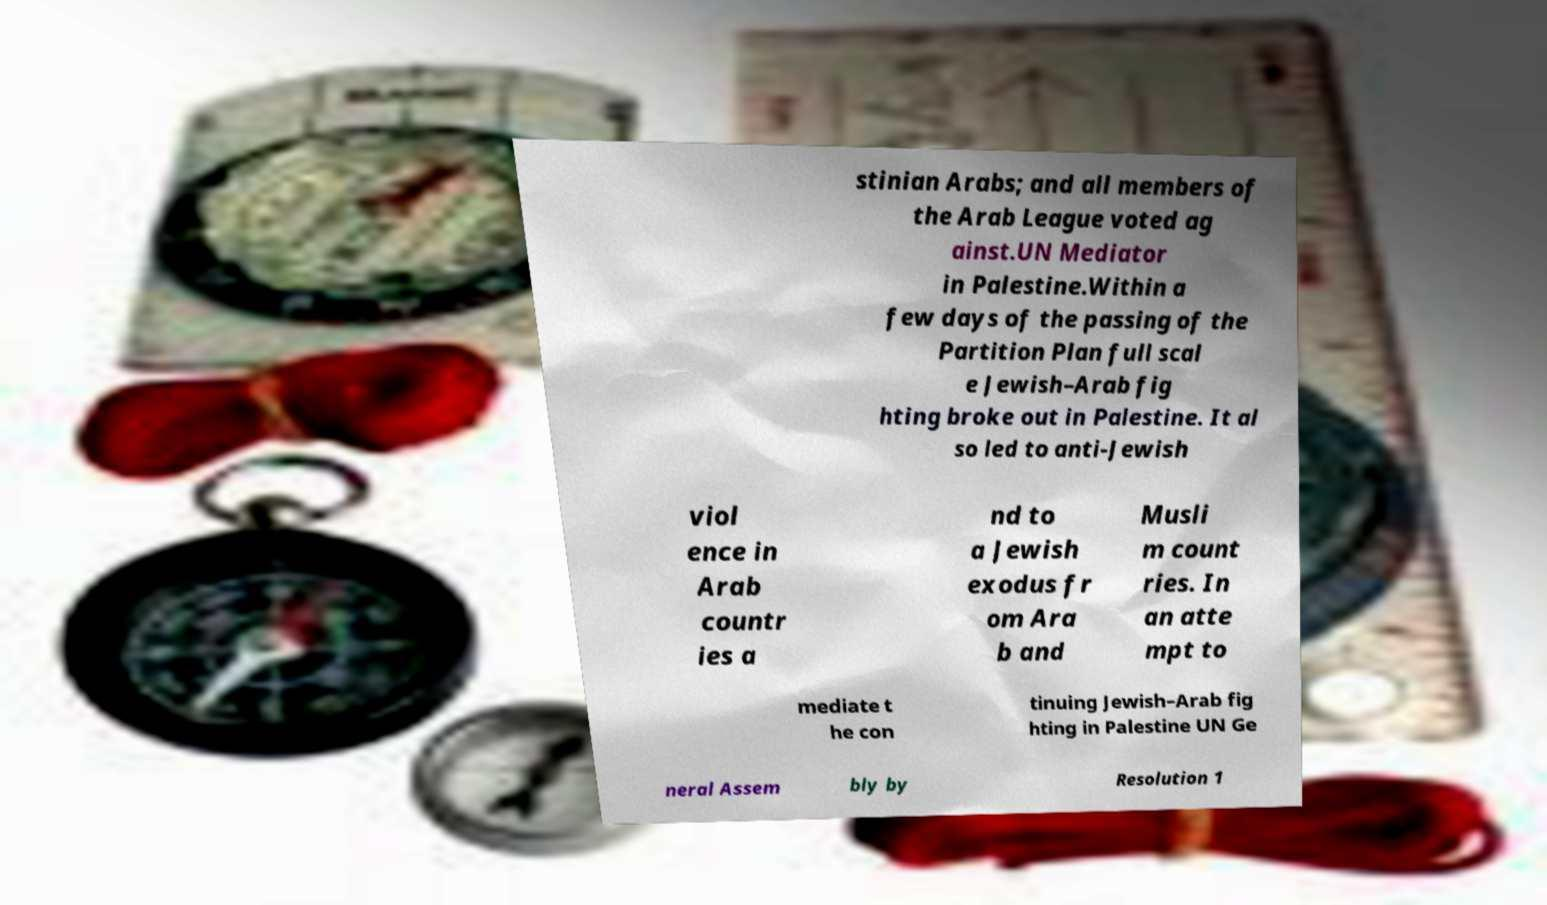For documentation purposes, I need the text within this image transcribed. Could you provide that? stinian Arabs; and all members of the Arab League voted ag ainst.UN Mediator in Palestine.Within a few days of the passing of the Partition Plan full scal e Jewish–Arab fig hting broke out in Palestine. It al so led to anti-Jewish viol ence in Arab countr ies a nd to a Jewish exodus fr om Ara b and Musli m count ries. In an atte mpt to mediate t he con tinuing Jewish–Arab fig hting in Palestine UN Ge neral Assem bly by Resolution 1 